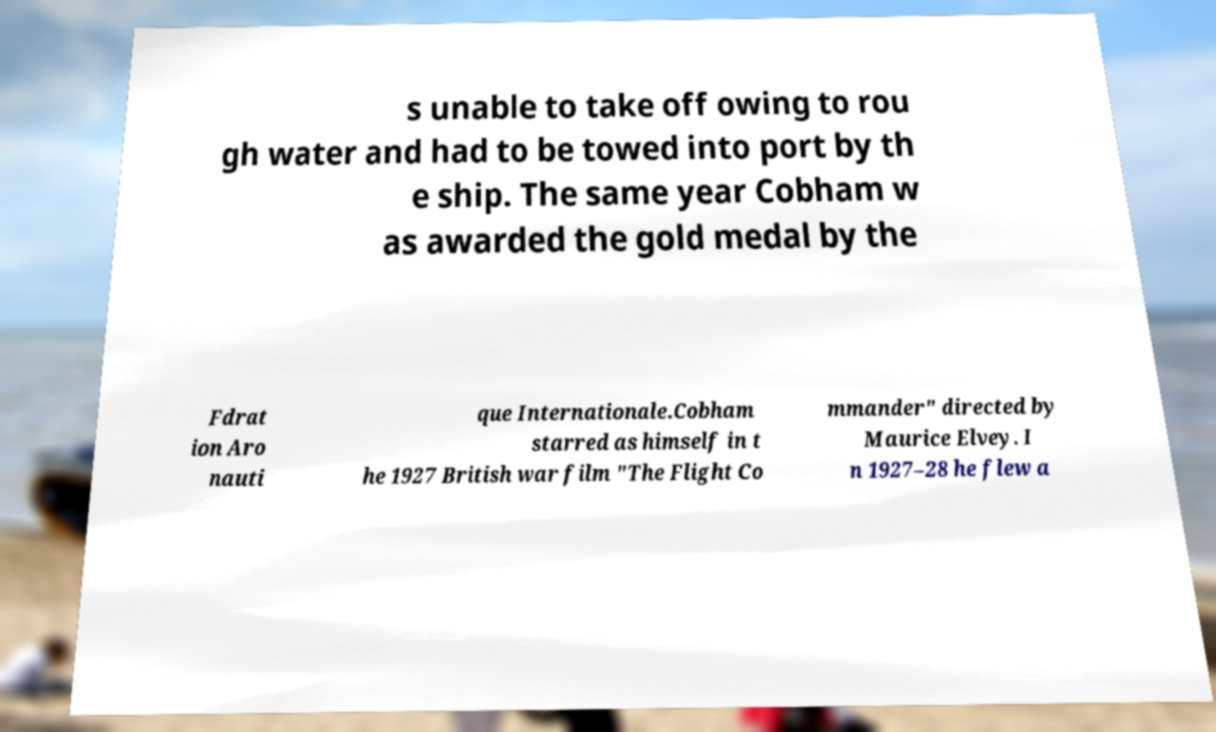Can you accurately transcribe the text from the provided image for me? s unable to take off owing to rou gh water and had to be towed into port by th e ship. The same year Cobham w as awarded the gold medal by the Fdrat ion Aro nauti que Internationale.Cobham starred as himself in t he 1927 British war film "The Flight Co mmander" directed by Maurice Elvey. I n 1927–28 he flew a 